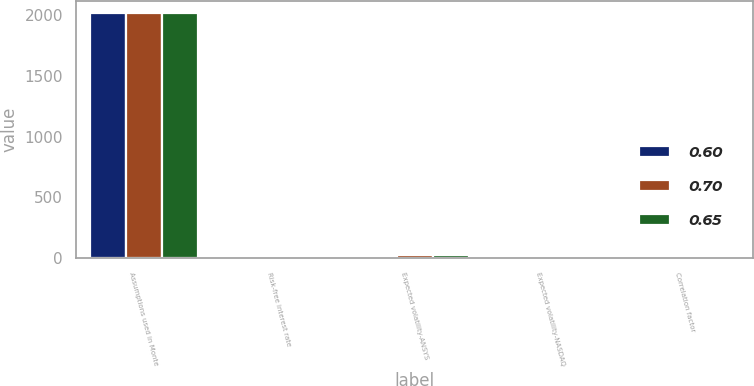Convert chart. <chart><loc_0><loc_0><loc_500><loc_500><stacked_bar_chart><ecel><fcel>Assumptions used in Monte<fcel>Risk-free interest rate<fcel>Expected volatility-ANSYS<fcel>Expected volatility-NASDAQ<fcel>Correlation factor<nl><fcel>0.6<fcel>2016<fcel>1<fcel>21<fcel>16<fcel>0.65<nl><fcel>0.7<fcel>2015<fcel>1.1<fcel>23<fcel>14<fcel>0.6<nl><fcel>0.65<fcel>2014<fcel>0.7<fcel>25<fcel>15<fcel>0.7<nl></chart> 